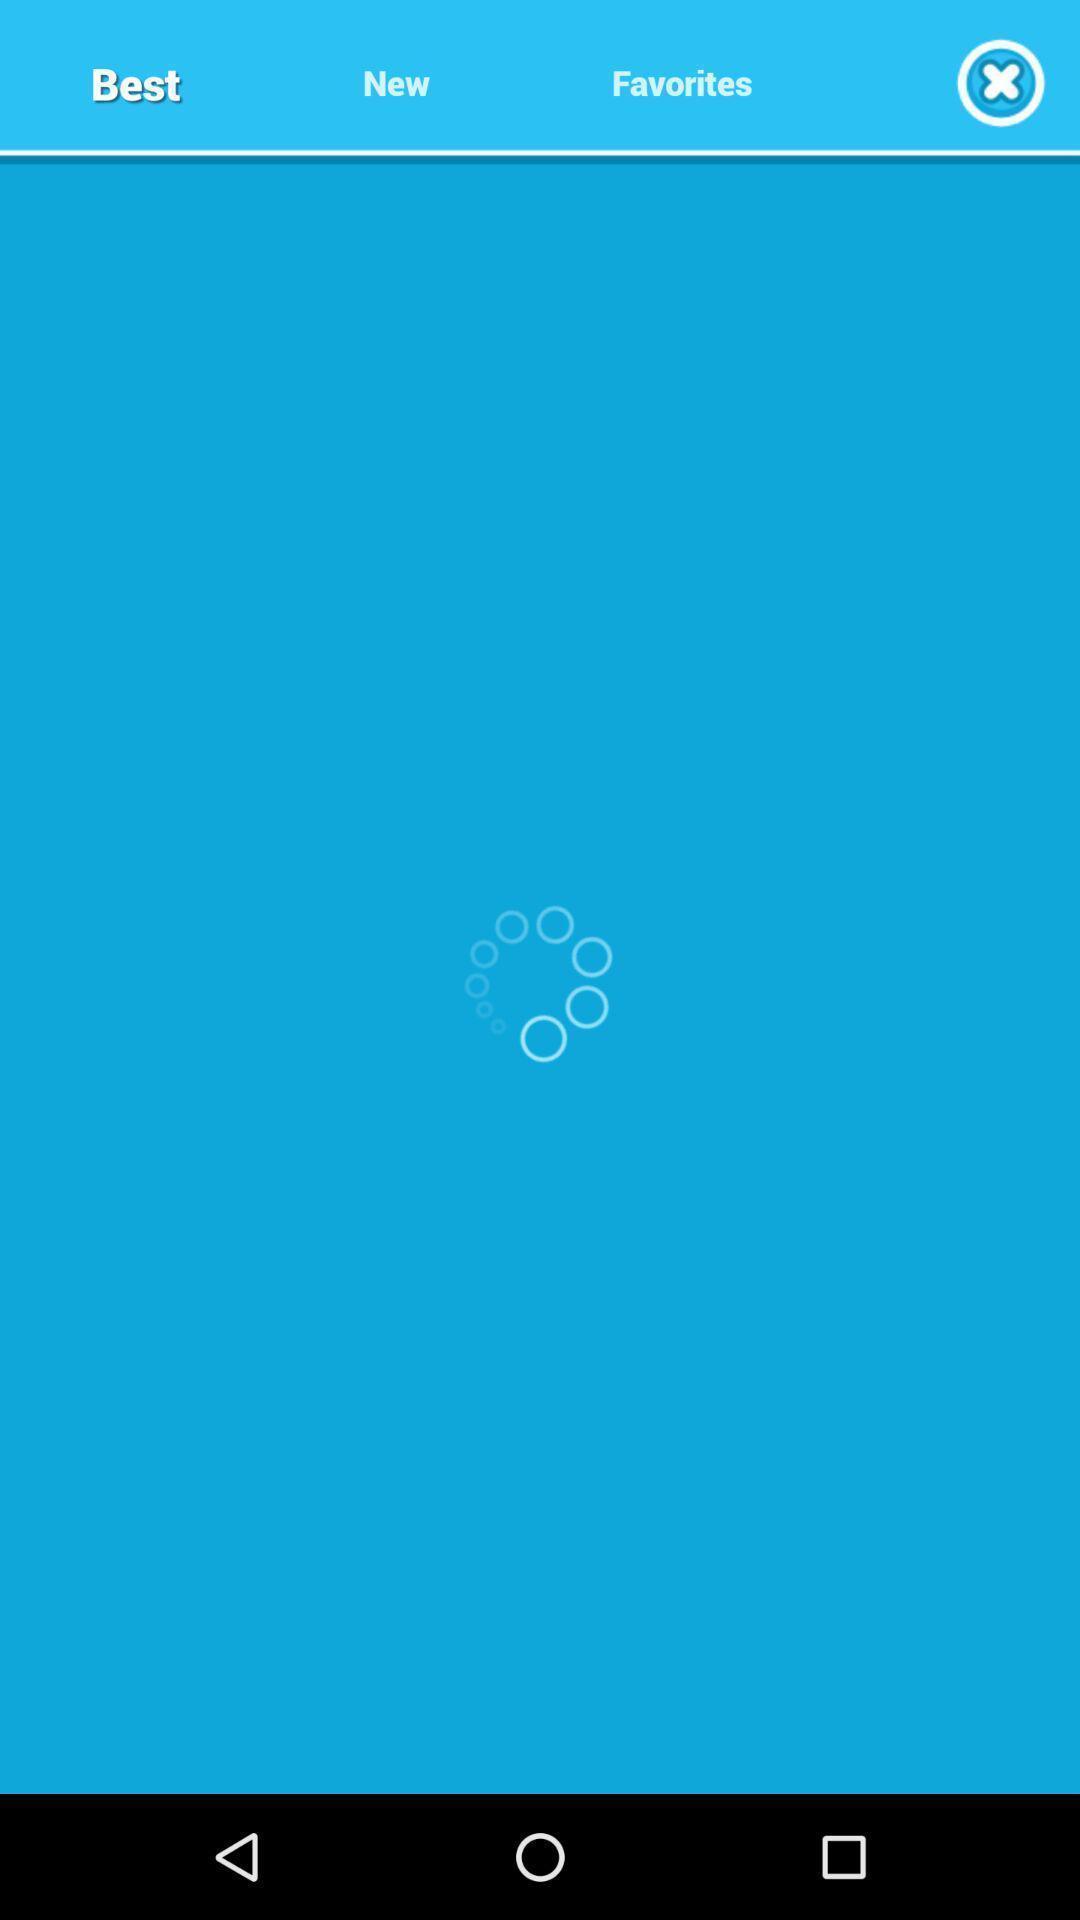Describe the visual elements of this screenshot. Screen shows a loading page. 